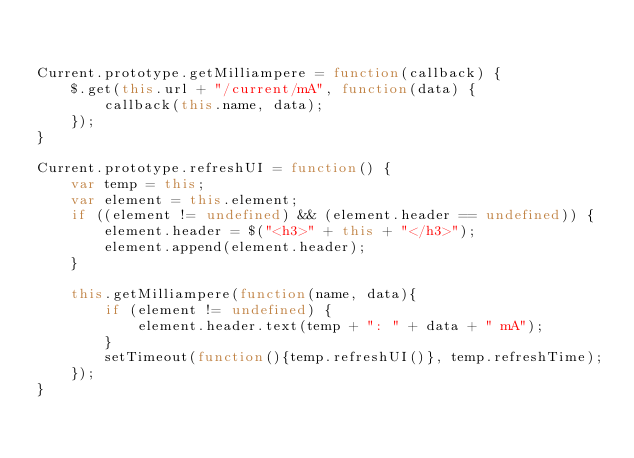Convert code to text. <code><loc_0><loc_0><loc_500><loc_500><_JavaScript_>

Current.prototype.getMilliampere = function(callback) {
	$.get(this.url + "/current/mA", function(data) {
		callback(this.name, data);
	});
}

Current.prototype.refreshUI = function() {
	var temp = this;
	var element = this.element;
	if ((element != undefined) && (element.header == undefined)) {
		element.header = $("<h3>" + this + "</h3>");
		element.append(element.header);
	}
	
	this.getMilliampere(function(name, data){
		if (element != undefined) {
			element.header.text(temp + ": " + data + " mA");
		}
		setTimeout(function(){temp.refreshUI()}, temp.refreshTime);
	});
}
</code> 